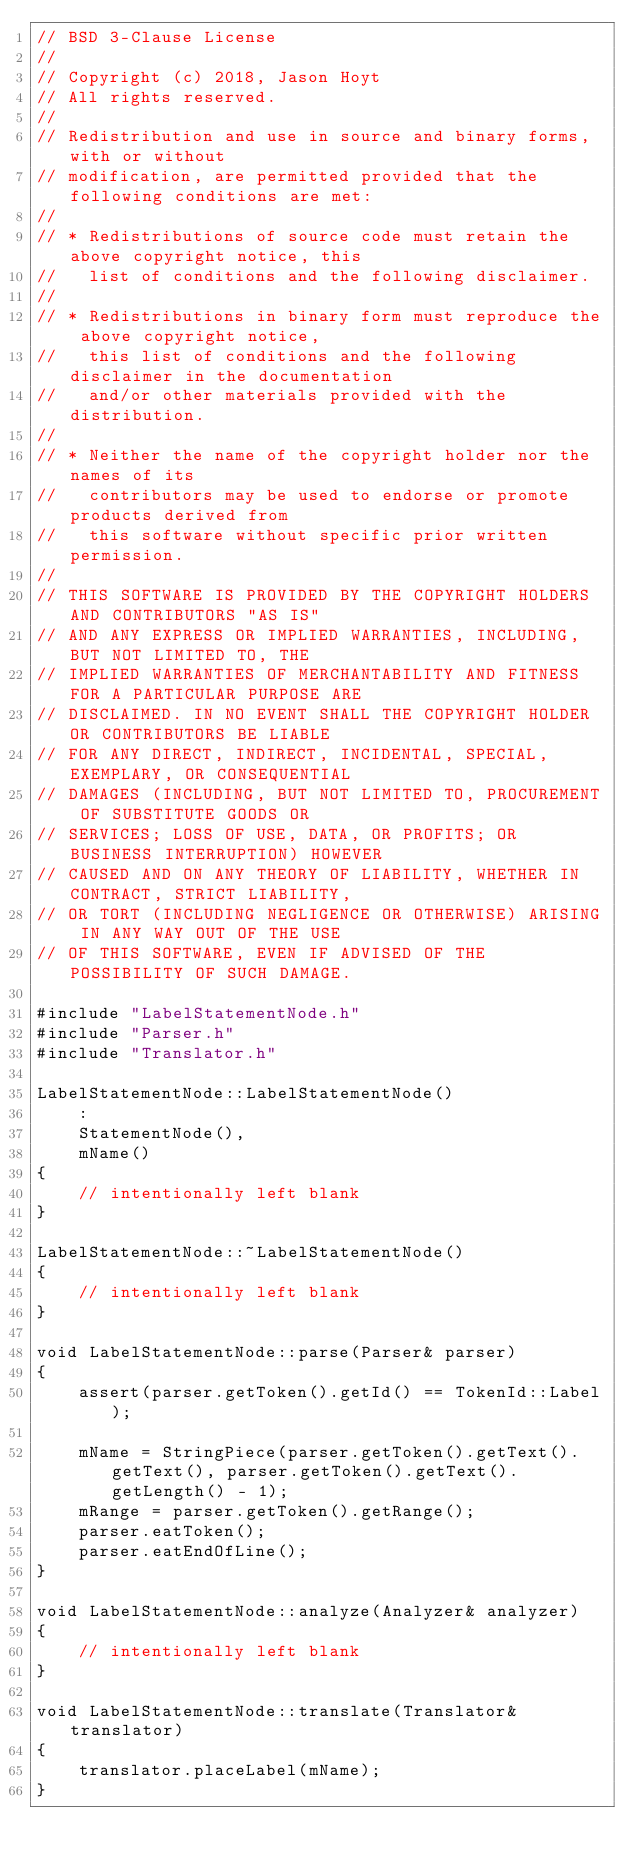<code> <loc_0><loc_0><loc_500><loc_500><_C++_>// BSD 3-Clause License
//
// Copyright (c) 2018, Jason Hoyt
// All rights reserved.
//
// Redistribution and use in source and binary forms, with or without
// modification, are permitted provided that the following conditions are met:
//
// * Redistributions of source code must retain the above copyright notice, this
//   list of conditions and the following disclaimer.
//
// * Redistributions in binary form must reproduce the above copyright notice,
//   this list of conditions and the following disclaimer in the documentation
//   and/or other materials provided with the distribution.
//
// * Neither the name of the copyright holder nor the names of its
//   contributors may be used to endorse or promote products derived from
//   this software without specific prior written permission.
//
// THIS SOFTWARE IS PROVIDED BY THE COPYRIGHT HOLDERS AND CONTRIBUTORS "AS IS"
// AND ANY EXPRESS OR IMPLIED WARRANTIES, INCLUDING, BUT NOT LIMITED TO, THE
// IMPLIED WARRANTIES OF MERCHANTABILITY AND FITNESS FOR A PARTICULAR PURPOSE ARE
// DISCLAIMED. IN NO EVENT SHALL THE COPYRIGHT HOLDER OR CONTRIBUTORS BE LIABLE
// FOR ANY DIRECT, INDIRECT, INCIDENTAL, SPECIAL, EXEMPLARY, OR CONSEQUENTIAL
// DAMAGES (INCLUDING, BUT NOT LIMITED TO, PROCUREMENT OF SUBSTITUTE GOODS OR
// SERVICES; LOSS OF USE, DATA, OR PROFITS; OR BUSINESS INTERRUPTION) HOWEVER
// CAUSED AND ON ANY THEORY OF LIABILITY, WHETHER IN CONTRACT, STRICT LIABILITY,
// OR TORT (INCLUDING NEGLIGENCE OR OTHERWISE) ARISING IN ANY WAY OUT OF THE USE
// OF THIS SOFTWARE, EVEN IF ADVISED OF THE POSSIBILITY OF SUCH DAMAGE.

#include "LabelStatementNode.h"
#include "Parser.h"
#include "Translator.h"

LabelStatementNode::LabelStatementNode()
    :
    StatementNode(),
    mName()
{
    // intentionally left blank
}

LabelStatementNode::~LabelStatementNode()
{
    // intentionally left blank
}

void LabelStatementNode::parse(Parser& parser)
{
    assert(parser.getToken().getId() == TokenId::Label);

    mName = StringPiece(parser.getToken().getText().getText(), parser.getToken().getText().getLength() - 1);
    mRange = parser.getToken().getRange();
    parser.eatToken();
    parser.eatEndOfLine();
}

void LabelStatementNode::analyze(Analyzer& analyzer)
{
    // intentionally left blank
}

void LabelStatementNode::translate(Translator& translator)
{
    translator.placeLabel(mName);
}
</code> 